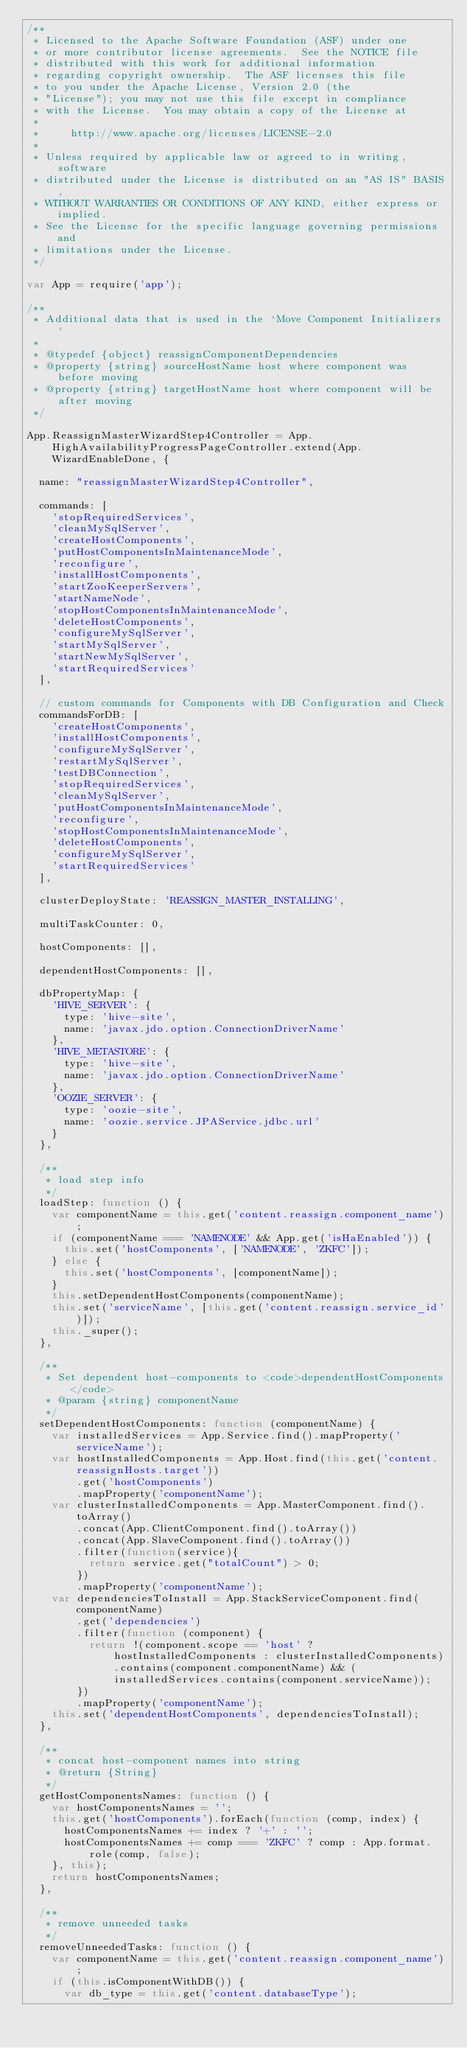Convert code to text. <code><loc_0><loc_0><loc_500><loc_500><_JavaScript_>/**
 * Licensed to the Apache Software Foundation (ASF) under one
 * or more contributor license agreements.  See the NOTICE file
 * distributed with this work for additional information
 * regarding copyright ownership.  The ASF licenses this file
 * to you under the Apache License, Version 2.0 (the
 * "License"); you may not use this file except in compliance
 * with the License.  You may obtain a copy of the License at
 *
 *     http://www.apache.org/licenses/LICENSE-2.0
 *
 * Unless required by applicable law or agreed to in writing, software
 * distributed under the License is distributed on an "AS IS" BASIS,
 * WITHOUT WARRANTIES OR CONDITIONS OF ANY KIND, either express or implied.
 * See the License for the specific language governing permissions and
 * limitations under the License.
 */

var App = require('app');

/**
 * Additional data that is used in the `Move Component Initializers`
 *
 * @typedef {object} reassignComponentDependencies
 * @property {string} sourceHostName host where component was before moving
 * @property {string} targetHostName host where component will be after moving
 */

App.ReassignMasterWizardStep4Controller = App.HighAvailabilityProgressPageController.extend(App.WizardEnableDone, {

  name: "reassignMasterWizardStep4Controller",

  commands: [
    'stopRequiredServices',
    'cleanMySqlServer',
    'createHostComponents',
    'putHostComponentsInMaintenanceMode',
    'reconfigure',
    'installHostComponents',
    'startZooKeeperServers',
    'startNameNode',
    'stopHostComponentsInMaintenanceMode',
    'deleteHostComponents',
    'configureMySqlServer',
    'startMySqlServer',
    'startNewMySqlServer',
    'startRequiredServices'
  ],

  // custom commands for Components with DB Configuration and Check
  commandsForDB: [
    'createHostComponents',
    'installHostComponents',
    'configureMySqlServer',
    'restartMySqlServer',
    'testDBConnection',
    'stopRequiredServices',
    'cleanMySqlServer',
    'putHostComponentsInMaintenanceMode',
    'reconfigure',
    'stopHostComponentsInMaintenanceMode',
    'deleteHostComponents',
    'configureMySqlServer',
    'startRequiredServices'
  ],

  clusterDeployState: 'REASSIGN_MASTER_INSTALLING',

  multiTaskCounter: 0,

  hostComponents: [],

  dependentHostComponents: [],

  dbPropertyMap: {
    'HIVE_SERVER': {
      type: 'hive-site',
      name: 'javax.jdo.option.ConnectionDriverName'
    },
    'HIVE_METASTORE': {
      type: 'hive-site',
      name: 'javax.jdo.option.ConnectionDriverName'
    },
    'OOZIE_SERVER': {
      type: 'oozie-site',
      name: 'oozie.service.JPAService.jdbc.url'
    }
  },

  /**
   * load step info
   */
  loadStep: function () {
    var componentName = this.get('content.reassign.component_name');
    if (componentName === 'NAMENODE' && App.get('isHaEnabled')) {
      this.set('hostComponents', ['NAMENODE', 'ZKFC']);
    } else {
      this.set('hostComponents', [componentName]);
    }
    this.setDependentHostComponents(componentName);
    this.set('serviceName', [this.get('content.reassign.service_id')]);
    this._super();
  },

  /**
   * Set dependent host-components to <code>dependentHostComponents</code>
   * @param {string} componentName
   */
  setDependentHostComponents: function (componentName) {
    var installedServices = App.Service.find().mapProperty('serviceName');
    var hostInstalledComponents = App.Host.find(this.get('content.reassignHosts.target'))
        .get('hostComponents')
        .mapProperty('componentName');
    var clusterInstalledComponents = App.MasterComponent.find().toArray()
        .concat(App.ClientComponent.find().toArray())
        .concat(App.SlaveComponent.find().toArray())
        .filter(function(service){
          return service.get("totalCount") > 0;
        })
        .mapProperty('componentName');
    var dependenciesToInstall = App.StackServiceComponent.find(componentName)
        .get('dependencies')
        .filter(function (component) {
          return !(component.scope == 'host' ? hostInstalledComponents : clusterInstalledComponents).contains(component.componentName) && (installedServices.contains(component.serviceName));
        })
        .mapProperty('componentName');
    this.set('dependentHostComponents', dependenciesToInstall);
  },

  /**
   * concat host-component names into string
   * @return {String}
   */
  getHostComponentsNames: function () {
    var hostComponentsNames = '';
    this.get('hostComponents').forEach(function (comp, index) {
      hostComponentsNames += index ? '+' : '';
      hostComponentsNames += comp === 'ZKFC' ? comp : App.format.role(comp, false);
    }, this);
    return hostComponentsNames;
  },

  /**
   * remove unneeded tasks
   */
  removeUnneededTasks: function () {
    var componentName = this.get('content.reassign.component_name');
    if (this.isComponentWithDB()) {
      var db_type = this.get('content.databaseType');</code> 